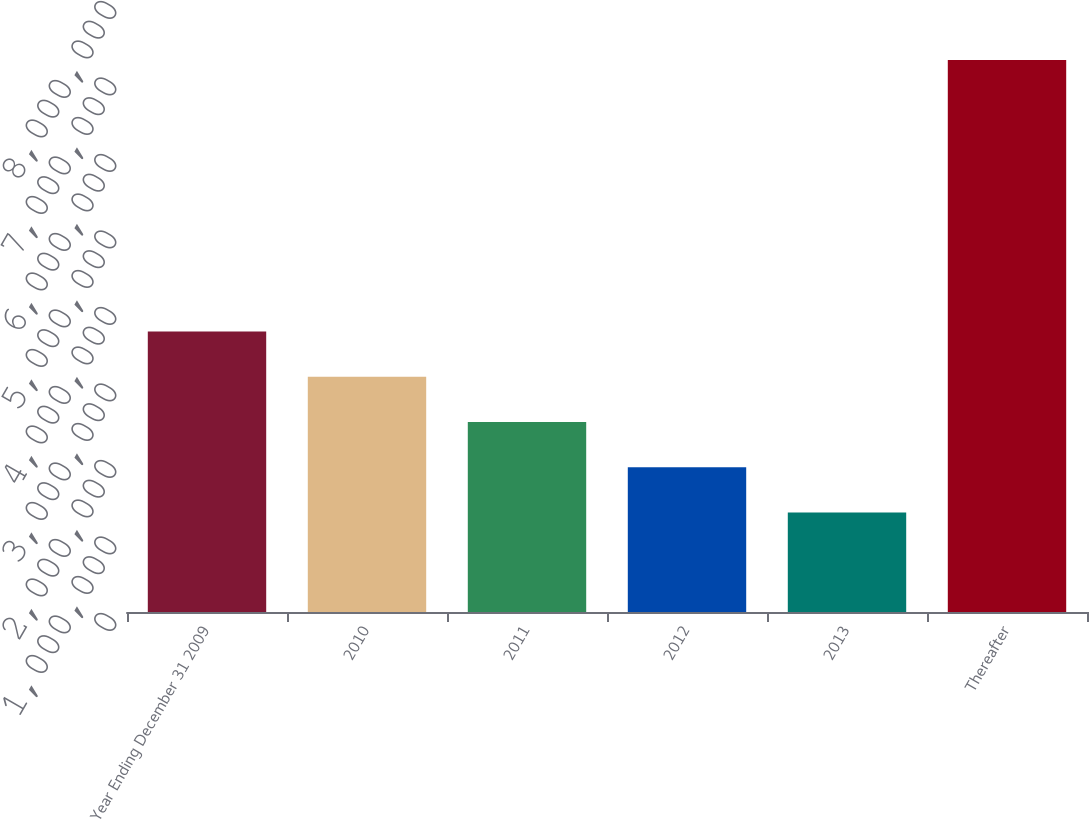Convert chart. <chart><loc_0><loc_0><loc_500><loc_500><bar_chart><fcel>Year Ending December 31 2009<fcel>2010<fcel>2011<fcel>2012<fcel>2013<fcel>Thereafter<nl><fcel>3.6664e+06<fcel>3.0748e+06<fcel>2.4832e+06<fcel>1.8916e+06<fcel>1.3e+06<fcel>7.216e+06<nl></chart> 